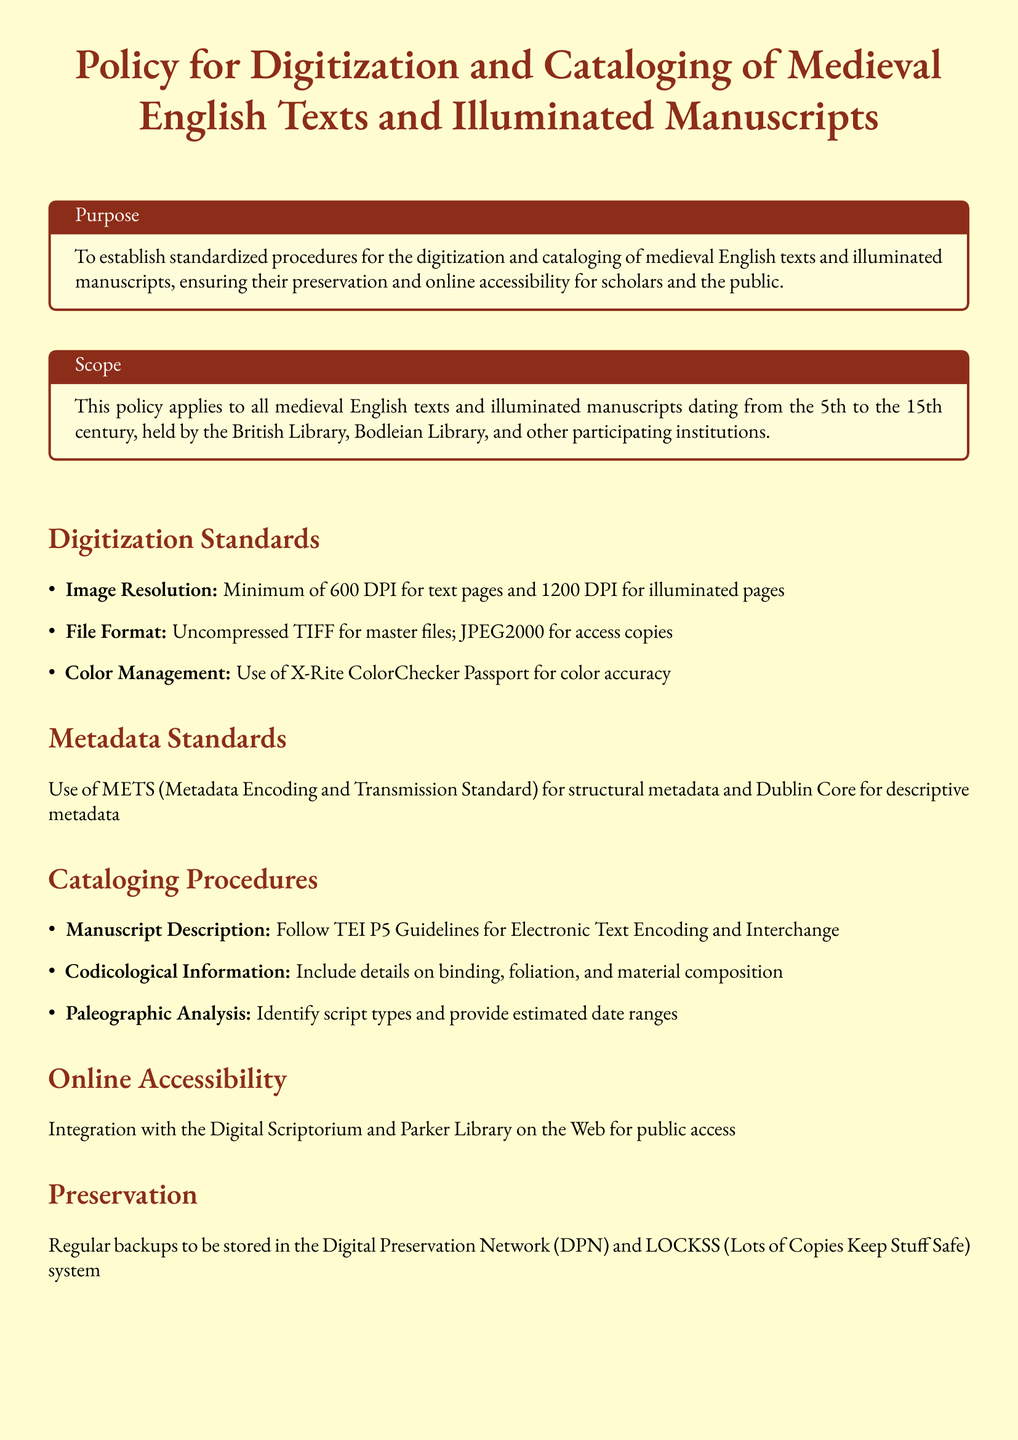what is the minimum image resolution for text pages? The document specifies a minimum of 600 DPI for text pages under the digitization standards.
Answer: 600 DPI what file format is required for master files? The policy states that uncompressed TIFF should be used for master files.
Answer: Uncompressed TIFF which libraries are participating in this policy? The document lists the British Library and Bodleian Library among participating institutions.
Answer: British Library, Bodleian Library what is the purpose of this policy document? The purpose is to establish standardized procedures for digitization and cataloging to ensure preservation and online accessibility.
Answer: To establish standardized procedures for the digitization and cataloging what system is used for regular backups? The policy mentions the Digital Preservation Network (DPN) and LOCKSS system for storing regular backups.
Answer: Digital Preservation Network (DPN) and LOCKSS which standard is used for structural metadata? The document states that METS (Metadata Encoding and Transmission Standard) is used for structural metadata.
Answer: METS what guidelines should manuscript descriptions follow? The document specifies that manuscript descriptions should follow TEI P5 Guidelines for Electronic Text Encoding and Interchange.
Answer: TEI P5 Guidelines what is the minimum image resolution for illuminated pages? A minimum of 1200 DPI is required for illuminated pages according to the digitization standards.
Answer: 1200 DPI which platform is mentioned for public access integration? The policy document mentions integration with the Digital Scriptorium for public access.
Answer: Digital Scriptorium 